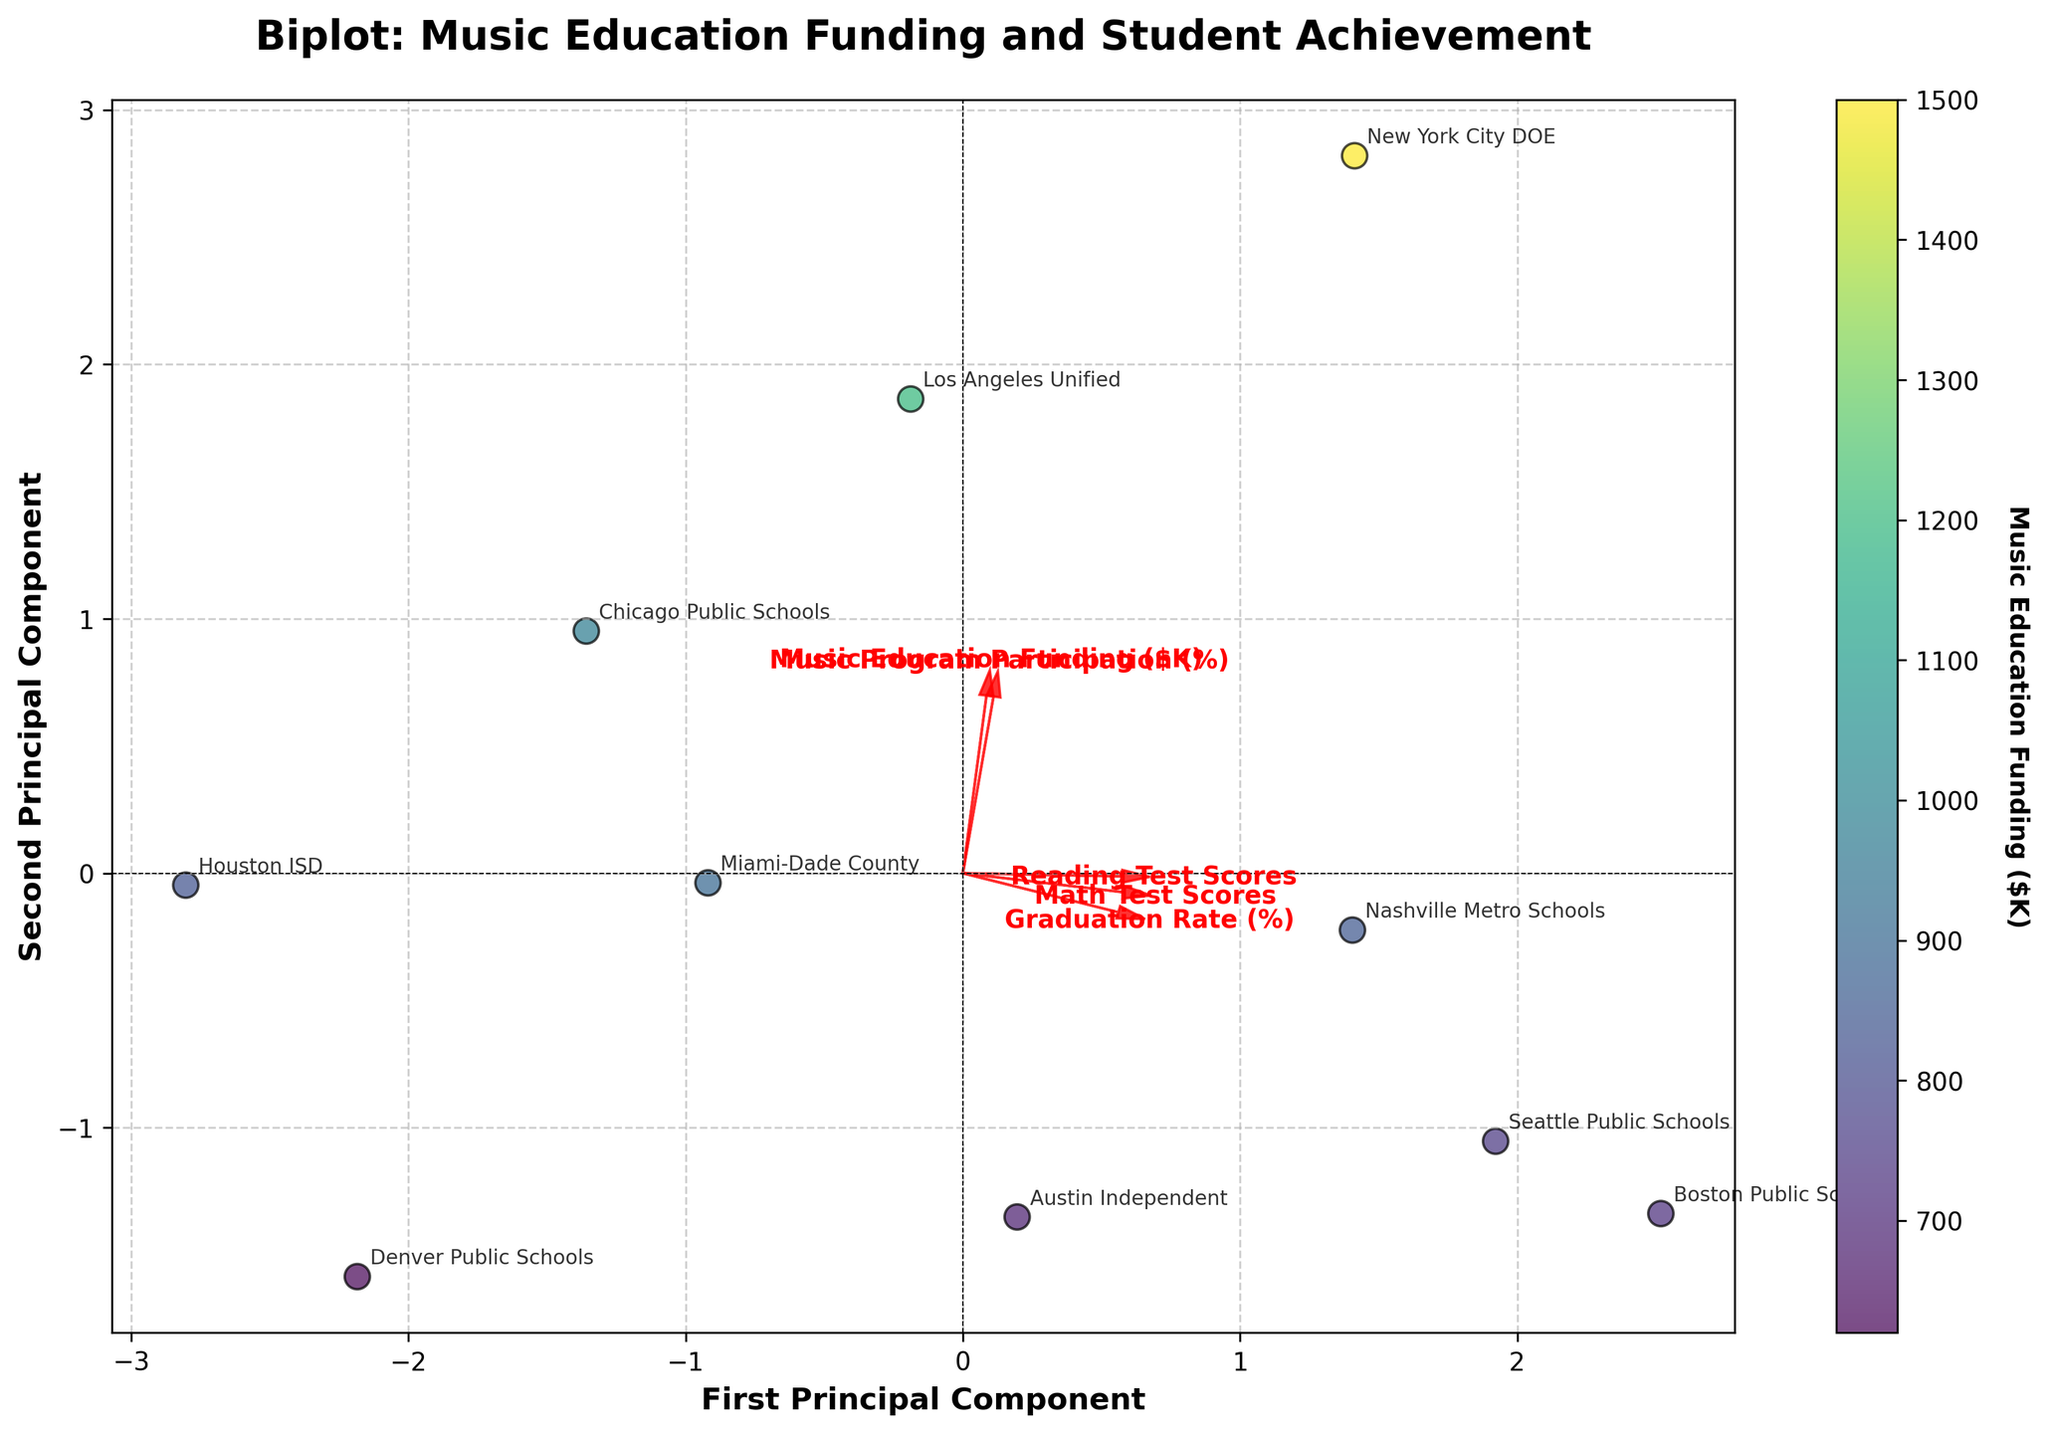What is the title of the figure? The title is usually displayed prominently at the top of the figure. It reads "Biplot: Music Education Funding and Student Achievement".
Answer: "Biplot: Music Education Funding and Student Achievement" How many principal components are displayed in the plot? The axes labels read "First Principal Component" and "Second Principal Component", suggesting that these are the two components displayed.
Answer: Two Which school district has the highest Music Education Funding and where is it located on the plot? The color scale indicates that the New York City DOE has the highest funding at $1500K. The school districts can be identified by their annotated names on the plot. New York City DOE should be located at the point with the most intense color according to the color bar.
Answer: New York City DOE Which variables have the largest influence on the first principal component and how can you tell? The direction and length of the arrows in the biplot represent the influence of the variables on the principal components. The longer the arrow along the first principal component (horizontal axis), the stronger the influence. You can observe the arrows for each variable to determine this.
Answer: "Math Test Scores" and "Graduation Rate (%)" Based on the plot, which school district has both relatively high Math Test Scores and Reading Test Scores? The plot shows scores through the projection of the points related to these variables. Boston Public Schools, near the high-end arrow direction for both scores, appears to have high values for both parameters.
Answer: Boston Public Schools Is there a positive relationship between Music Education Funding and Math Test Scores? Observing the directions of the arrows and individual points, if the arrow for "Music Education Funding ($K)" and "Math Test Scores" point in roughly the same direction, and school districts with higher funding tend to cluster where the Math Test Scores arrow points. This is an indication.
Answer: Yes Which variable appears the most aligned with "Music Program Participation (%)" and why? In a biplot, the arrows that are the most parallel indicate high collinearity. "Reading Test Scores" appear more aligned with "Music Program Participation (%)" given they point nearly in the same direction.
Answer: "Reading Test Scores" Does the length of the arrow for "Graduation Rate (%)" suggest it is a significant factor in the variability captured by the first two principal components? Arrows that are longer imply a greater contribution to the principal component axes. "Graduation Rate (%)" has a relatively long arrow, indicating it’s a significant factor.
Answer: Yes Which school district has the lowest placement on the first principal component? The point furthest to the left along the first principal component axis represents the lowest value. Observing the annotated names, it is likely Austin Independent, given their characteristic lower funding and scores.
Answer: Austin Independent 